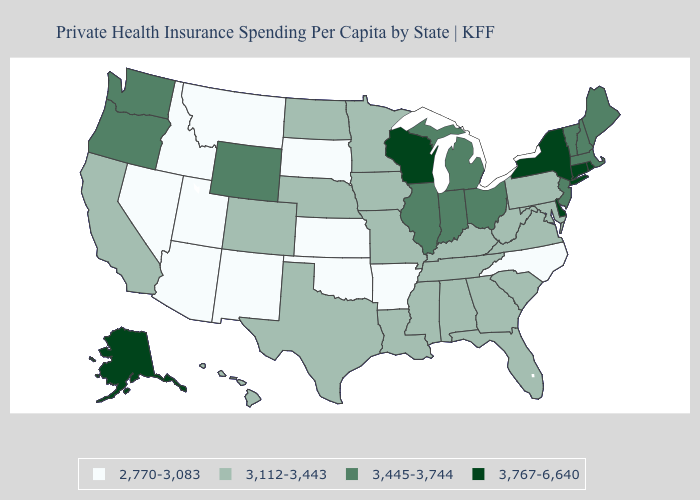Does the first symbol in the legend represent the smallest category?
Short answer required. Yes. What is the highest value in the South ?
Give a very brief answer. 3,767-6,640. Which states hav the highest value in the Northeast?
Quick response, please. Connecticut, New York, Rhode Island. Does the map have missing data?
Be succinct. No. Name the states that have a value in the range 3,445-3,744?
Give a very brief answer. Illinois, Indiana, Maine, Massachusetts, Michigan, New Hampshire, New Jersey, Ohio, Oregon, Vermont, Washington, Wyoming. Is the legend a continuous bar?
Concise answer only. No. Name the states that have a value in the range 3,445-3,744?
Be succinct. Illinois, Indiana, Maine, Massachusetts, Michigan, New Hampshire, New Jersey, Ohio, Oregon, Vermont, Washington, Wyoming. Name the states that have a value in the range 3,112-3,443?
Concise answer only. Alabama, California, Colorado, Florida, Georgia, Hawaii, Iowa, Kentucky, Louisiana, Maryland, Minnesota, Mississippi, Missouri, Nebraska, North Dakota, Pennsylvania, South Carolina, Tennessee, Texas, Virginia, West Virginia. Does Louisiana have the highest value in the USA?
Quick response, please. No. What is the value of Montana?
Concise answer only. 2,770-3,083. Which states have the lowest value in the MidWest?
Give a very brief answer. Kansas, South Dakota. Among the states that border Maine , which have the lowest value?
Quick response, please. New Hampshire. Does Oregon have the lowest value in the West?
Quick response, please. No. Which states have the lowest value in the USA?
Be succinct. Arizona, Arkansas, Idaho, Kansas, Montana, Nevada, New Mexico, North Carolina, Oklahoma, South Dakota, Utah. Does Wisconsin have the highest value in the USA?
Give a very brief answer. Yes. 